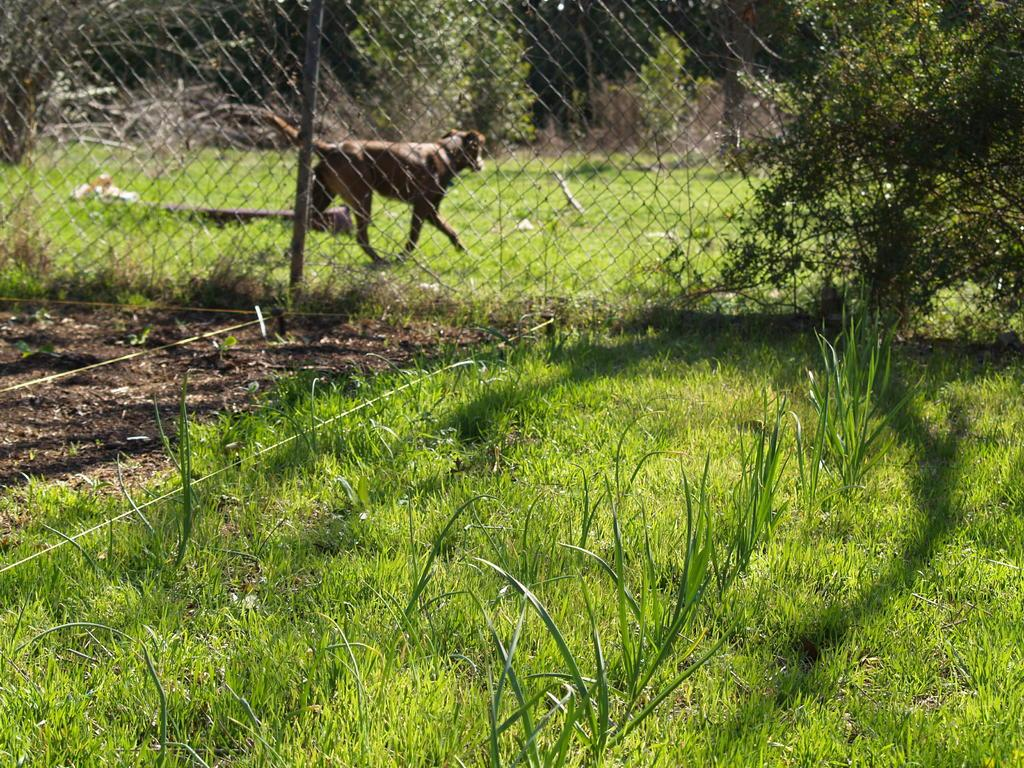What type of vegetation is present in the image? There is grass and plants in the image. What structure can be seen in the image? There is a fence in the image. What animal is visible in the image? A dog is walking behind the fence. What else can be seen in the image besides the vegetation and fence? There are trees in the image. How many women are sitting on the cream-colored pigs in the image? There are no women or cream-colored pigs present in the image. 